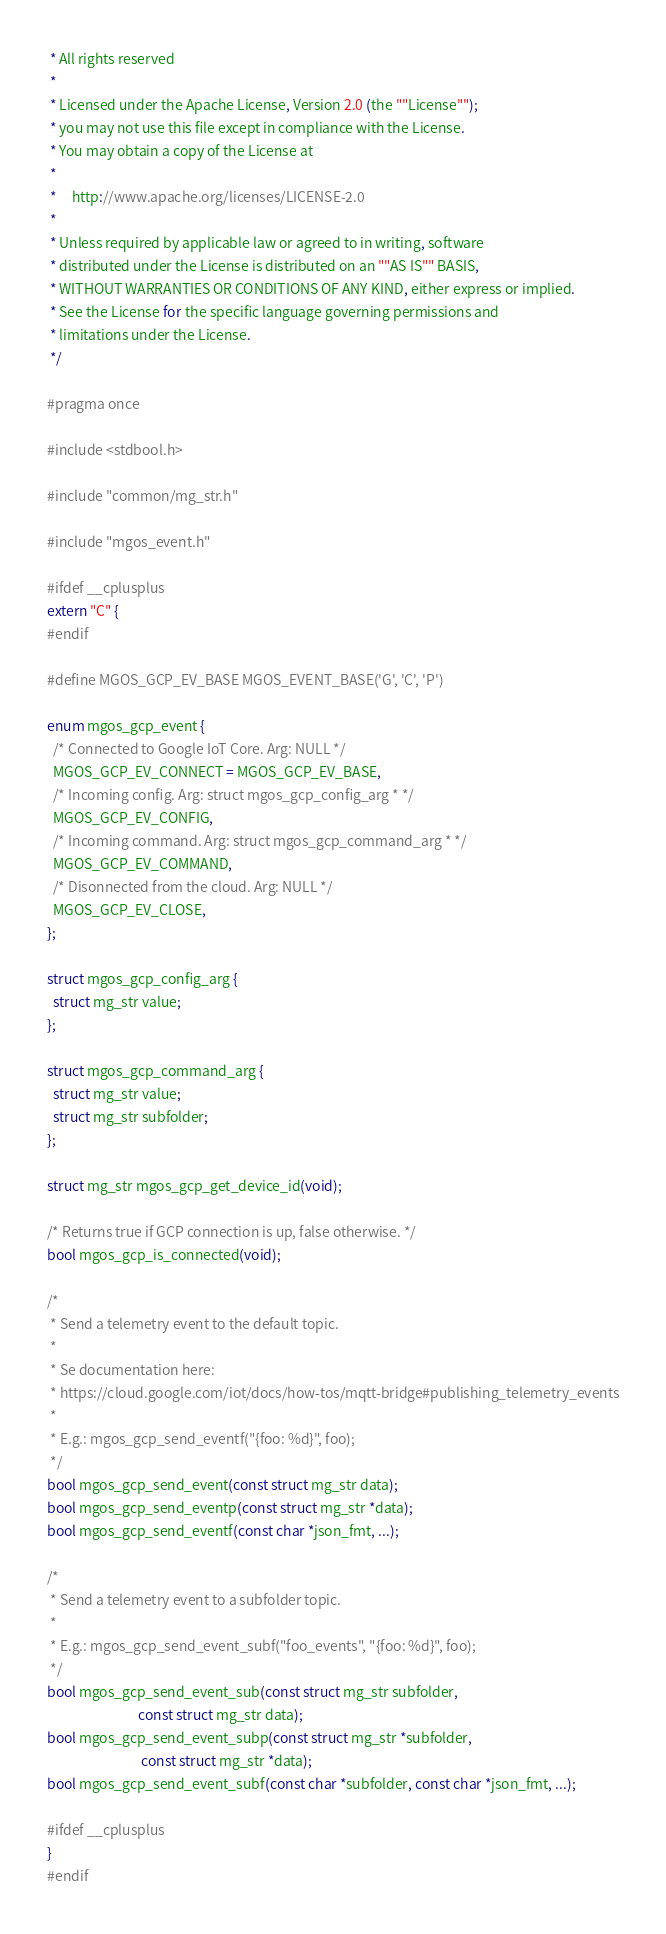<code> <loc_0><loc_0><loc_500><loc_500><_C_> * All rights reserved
 *
 * Licensed under the Apache License, Version 2.0 (the ""License"");
 * you may not use this file except in compliance with the License.
 * You may obtain a copy of the License at
 *
 *     http://www.apache.org/licenses/LICENSE-2.0
 *
 * Unless required by applicable law or agreed to in writing, software
 * distributed under the License is distributed on an ""AS IS"" BASIS,
 * WITHOUT WARRANTIES OR CONDITIONS OF ANY KIND, either express or implied.
 * See the License for the specific language governing permissions and
 * limitations under the License.
 */

#pragma once

#include <stdbool.h>

#include "common/mg_str.h"

#include "mgos_event.h"

#ifdef __cplusplus
extern "C" {
#endif

#define MGOS_GCP_EV_BASE MGOS_EVENT_BASE('G', 'C', 'P')

enum mgos_gcp_event {
  /* Connected to Google IoT Core. Arg: NULL */
  MGOS_GCP_EV_CONNECT = MGOS_GCP_EV_BASE,
  /* Incoming config. Arg: struct mgos_gcp_config_arg * */
  MGOS_GCP_EV_CONFIG,
  /* Incoming command. Arg: struct mgos_gcp_command_arg * */
  MGOS_GCP_EV_COMMAND,
  /* Disonnected from the cloud. Arg: NULL */
  MGOS_GCP_EV_CLOSE,
};

struct mgos_gcp_config_arg {
  struct mg_str value;
};

struct mgos_gcp_command_arg {
  struct mg_str value;
  struct mg_str subfolder;
};

struct mg_str mgos_gcp_get_device_id(void);

/* Returns true if GCP connection is up, false otherwise. */
bool mgos_gcp_is_connected(void);

/*
 * Send a telemetry event to the default topic.
 *
 * Se documentation here:
 * https://cloud.google.com/iot/docs/how-tos/mqtt-bridge#publishing_telemetry_events
 *
 * E.g.: mgos_gcp_send_eventf("{foo: %d}", foo);
 */
bool mgos_gcp_send_event(const struct mg_str data);
bool mgos_gcp_send_eventp(const struct mg_str *data);
bool mgos_gcp_send_eventf(const char *json_fmt, ...);

/*
 * Send a telemetry event to a subfolder topic.
 *
 * E.g.: mgos_gcp_send_event_subf("foo_events", "{foo: %d}", foo);
 */
bool mgos_gcp_send_event_sub(const struct mg_str subfolder,
                             const struct mg_str data);
bool mgos_gcp_send_event_subp(const struct mg_str *subfolder,
                              const struct mg_str *data);
bool mgos_gcp_send_event_subf(const char *subfolder, const char *json_fmt, ...);

#ifdef __cplusplus
}
#endif
</code> 